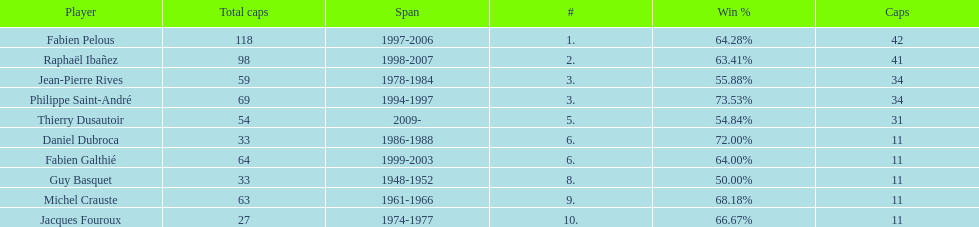Which player has the highest win percentage? Philippe Saint-André. 